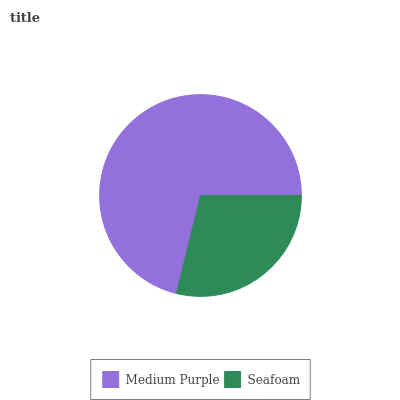Is Seafoam the minimum?
Answer yes or no. Yes. Is Medium Purple the maximum?
Answer yes or no. Yes. Is Seafoam the maximum?
Answer yes or no. No. Is Medium Purple greater than Seafoam?
Answer yes or no. Yes. Is Seafoam less than Medium Purple?
Answer yes or no. Yes. Is Seafoam greater than Medium Purple?
Answer yes or no. No. Is Medium Purple less than Seafoam?
Answer yes or no. No. Is Medium Purple the high median?
Answer yes or no. Yes. Is Seafoam the low median?
Answer yes or no. Yes. Is Seafoam the high median?
Answer yes or no. No. Is Medium Purple the low median?
Answer yes or no. No. 